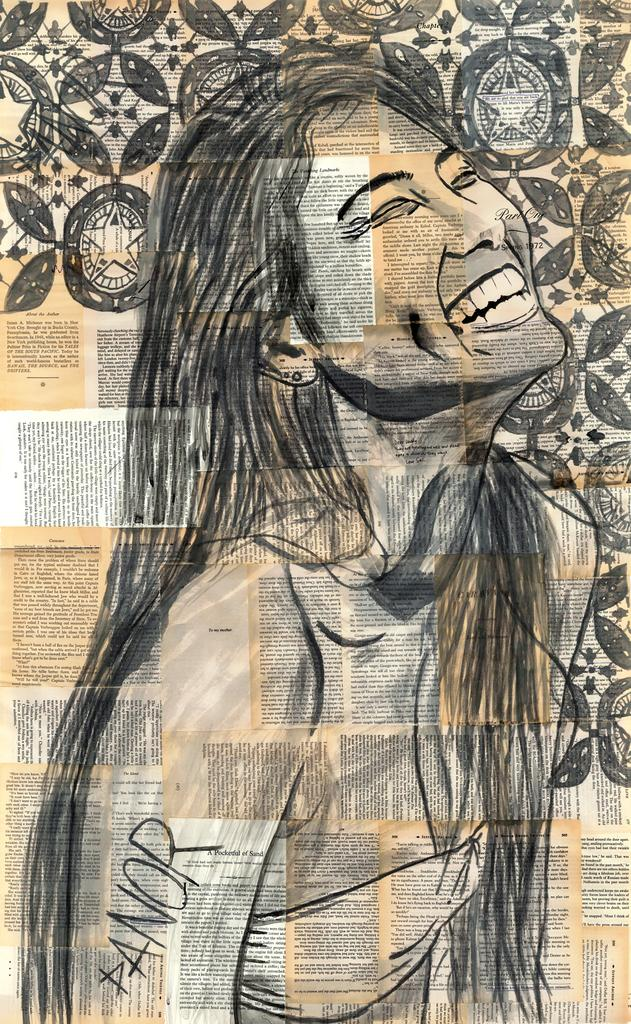Provide a one-sentence caption for the provided image. a drawing portrait of an Asian woman smiling with panor signing it. 